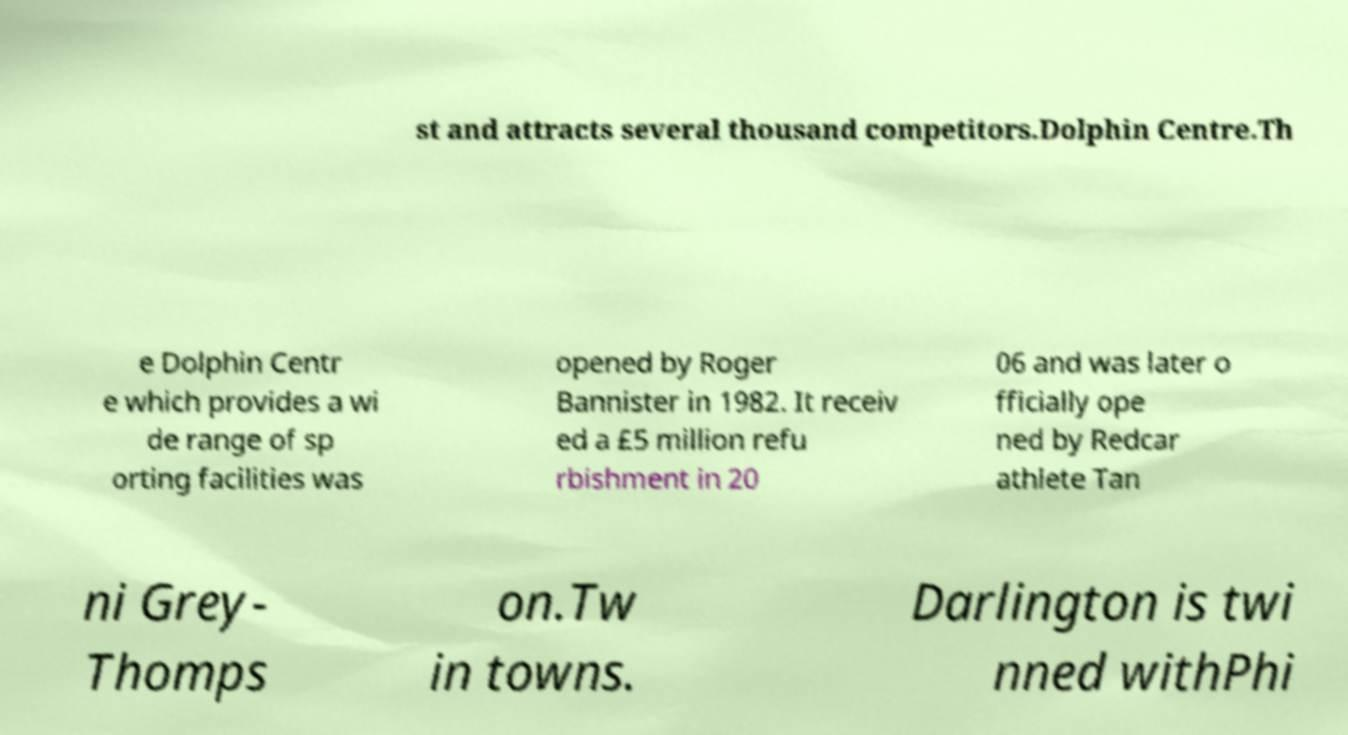Can you read and provide the text displayed in the image?This photo seems to have some interesting text. Can you extract and type it out for me? st and attracts several thousand competitors.Dolphin Centre.Th e Dolphin Centr e which provides a wi de range of sp orting facilities was opened by Roger Bannister in 1982. It receiv ed a £5 million refu rbishment in 20 06 and was later o fficially ope ned by Redcar athlete Tan ni Grey- Thomps on.Tw in towns. Darlington is twi nned withPhi 